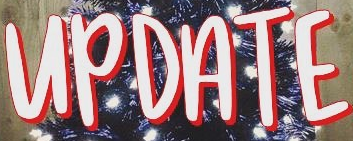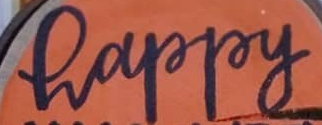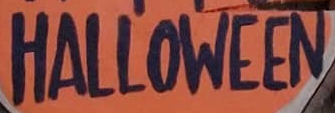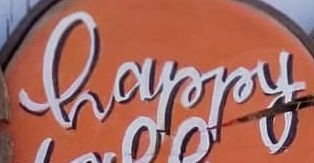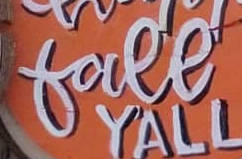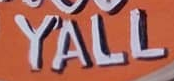Read the text content from these images in order, separated by a semicolon. UPDATE; happy; HALLOWEEN; happy; free; YALL 